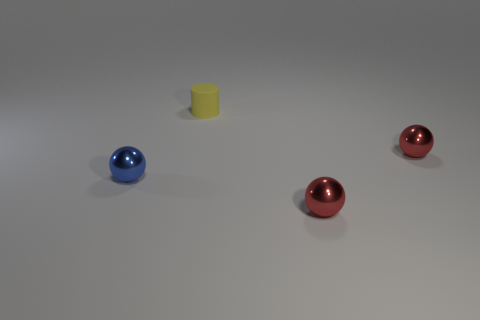Subtract all cylinders. How many objects are left? 3 Subtract 1 cylinders. How many cylinders are left? 0 Subtract all brown spheres. Subtract all purple blocks. How many spheres are left? 3 Subtract all green cylinders. How many red balls are left? 2 Subtract all yellow rubber things. Subtract all balls. How many objects are left? 0 Add 3 small rubber things. How many small rubber things are left? 4 Add 1 tiny blue blocks. How many tiny blue blocks exist? 1 Add 2 red metallic objects. How many objects exist? 6 Subtract all red balls. How many balls are left? 1 Subtract all small red metallic spheres. How many spheres are left? 1 